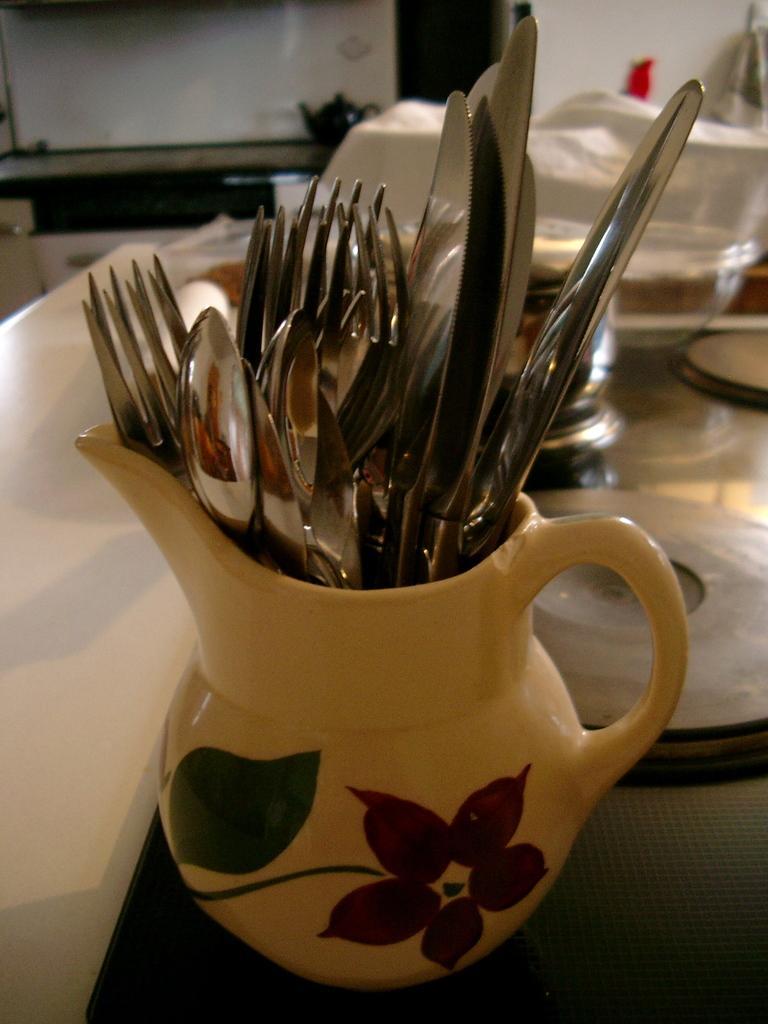Describe this image in one or two sentences. In this picture we can see forks, spoons, knives are in the jug, and the jug, plates, bowls are on top of the table. 